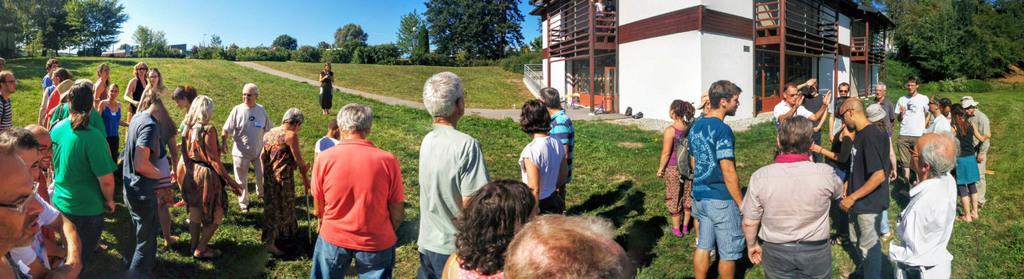Could you give a brief overview of what you see in this image? In this image, we can see some people standing on the grass, we can see the green grass on the ground, there is a house, we can see some trees, at the top there is a blue sky. 